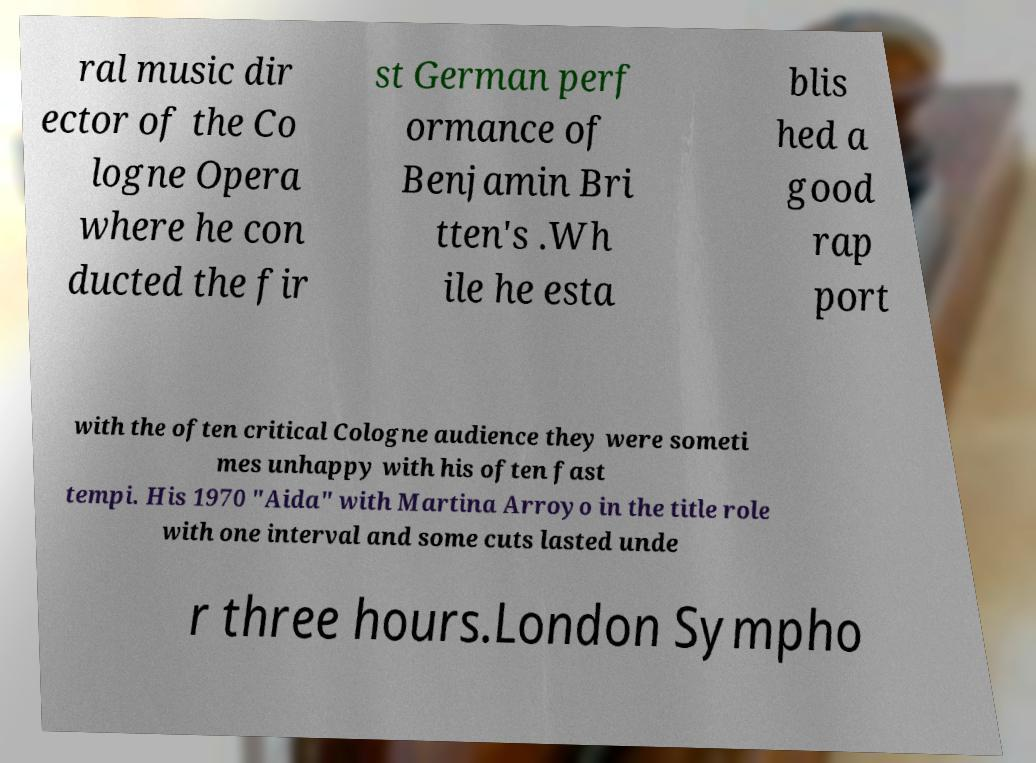Can you accurately transcribe the text from the provided image for me? ral music dir ector of the Co logne Opera where he con ducted the fir st German perf ormance of Benjamin Bri tten's .Wh ile he esta blis hed a good rap port with the often critical Cologne audience they were someti mes unhappy with his often fast tempi. His 1970 "Aida" with Martina Arroyo in the title role with one interval and some cuts lasted unde r three hours.London Sympho 